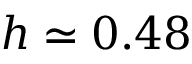<formula> <loc_0><loc_0><loc_500><loc_500>h \simeq 0 . 4 8</formula> 